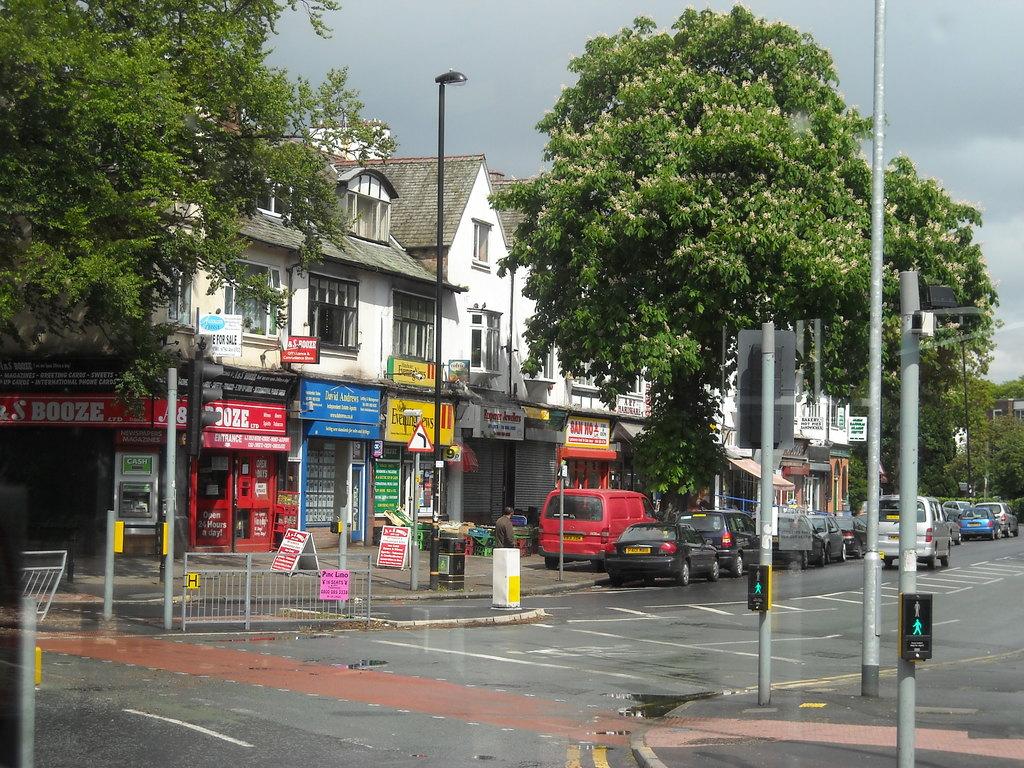What does the red sign say?
Keep it short and to the point. Booze. What does the store with the red sign sell?
Ensure brevity in your answer.  Booze. 